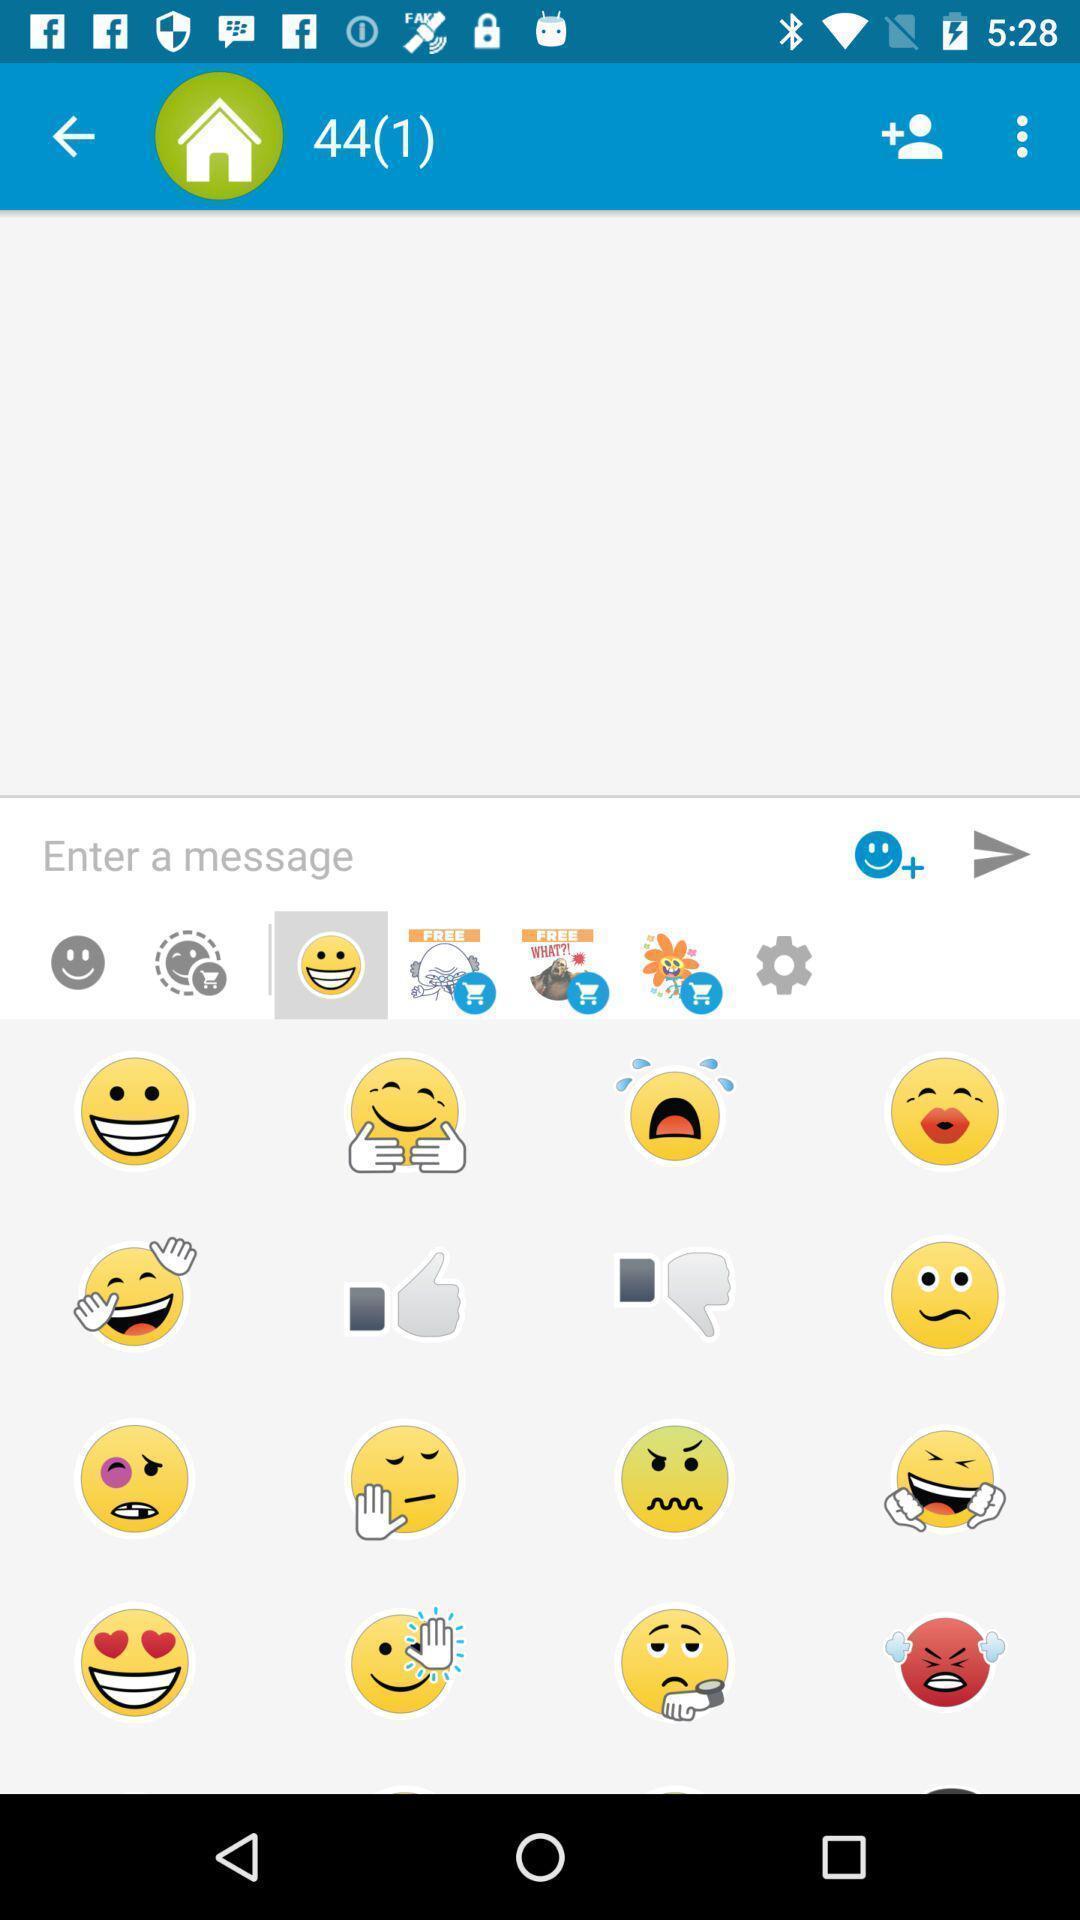Give me a summary of this screen capture. Page showing different emojis. 